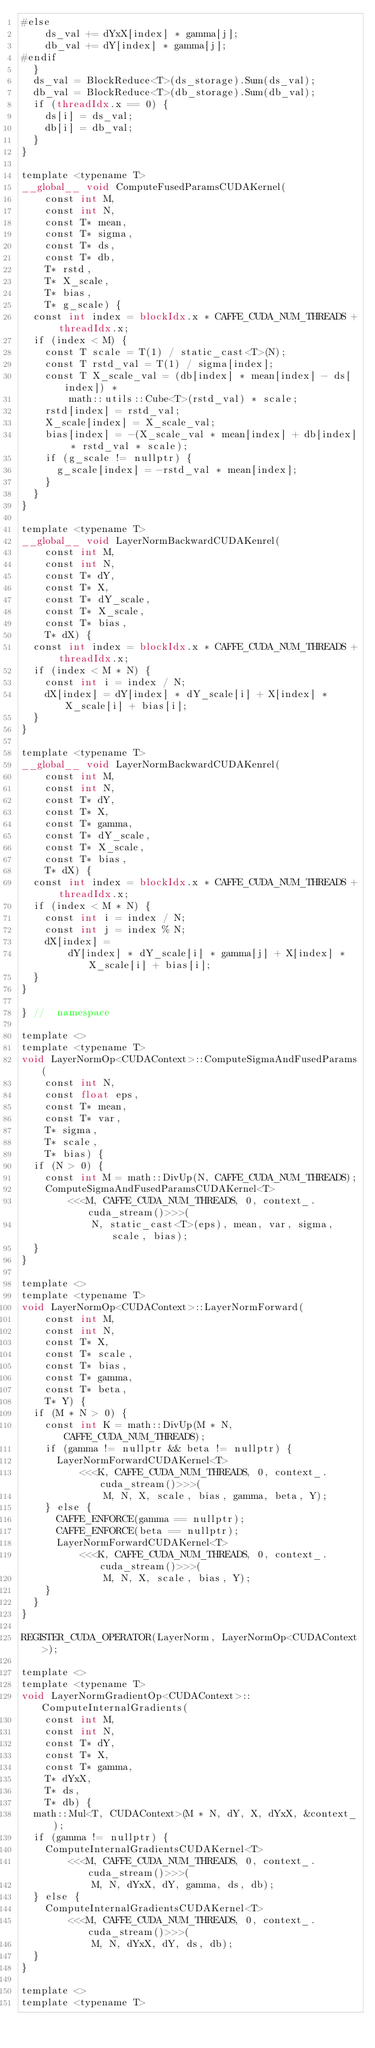Convert code to text. <code><loc_0><loc_0><loc_500><loc_500><_Cuda_>#else
    ds_val += dYxX[index] * gamma[j];
    db_val += dY[index] * gamma[j];
#endif
  }
  ds_val = BlockReduce<T>(ds_storage).Sum(ds_val);
  db_val = BlockReduce<T>(db_storage).Sum(db_val);
  if (threadIdx.x == 0) {
    ds[i] = ds_val;
    db[i] = db_val;
  }
}

template <typename T>
__global__ void ComputeFusedParamsCUDAKernel(
    const int M,
    const int N,
    const T* mean,
    const T* sigma,
    const T* ds,
    const T* db,
    T* rstd,
    T* X_scale,
    T* bias,
    T* g_scale) {
  const int index = blockIdx.x * CAFFE_CUDA_NUM_THREADS + threadIdx.x;
  if (index < M) {
    const T scale = T(1) / static_cast<T>(N);
    const T rstd_val = T(1) / sigma[index];
    const T X_scale_val = (db[index] * mean[index] - ds[index]) *
        math::utils::Cube<T>(rstd_val) * scale;
    rstd[index] = rstd_val;
    X_scale[index] = X_scale_val;
    bias[index] = -(X_scale_val * mean[index] + db[index] * rstd_val * scale);
    if (g_scale != nullptr) {
      g_scale[index] = -rstd_val * mean[index];
    }
  }
}

template <typename T>
__global__ void LayerNormBackwardCUDAKenrel(
    const int M,
    const int N,
    const T* dY,
    const T* X,
    const T* dY_scale,
    const T* X_scale,
    const T* bias,
    T* dX) {
  const int index = blockIdx.x * CAFFE_CUDA_NUM_THREADS + threadIdx.x;
  if (index < M * N) {
    const int i = index / N;
    dX[index] = dY[index] * dY_scale[i] + X[index] * X_scale[i] + bias[i];
  }
}

template <typename T>
__global__ void LayerNormBackwardCUDAKenrel(
    const int M,
    const int N,
    const T* dY,
    const T* X,
    const T* gamma,
    const T* dY_scale,
    const T* X_scale,
    const T* bias,
    T* dX) {
  const int index = blockIdx.x * CAFFE_CUDA_NUM_THREADS + threadIdx.x;
  if (index < M * N) {
    const int i = index / N;
    const int j = index % N;
    dX[index] =
        dY[index] * dY_scale[i] * gamma[j] + X[index] * X_scale[i] + bias[i];
  }
}

} //  namespace

template <>
template <typename T>
void LayerNormOp<CUDAContext>::ComputeSigmaAndFusedParams(
    const int N,
    const float eps,
    const T* mean,
    const T* var,
    T* sigma,
    T* scale,
    T* bias) {
  if (N > 0) {
    const int M = math::DivUp(N, CAFFE_CUDA_NUM_THREADS);
    ComputeSigmaAndFusedParamsCUDAKernel<T>
        <<<M, CAFFE_CUDA_NUM_THREADS, 0, context_.cuda_stream()>>>(
            N, static_cast<T>(eps), mean, var, sigma, scale, bias);
  }
}

template <>
template <typename T>
void LayerNormOp<CUDAContext>::LayerNormForward(
    const int M,
    const int N,
    const T* X,
    const T* scale,
    const T* bias,
    const T* gamma,
    const T* beta,
    T* Y) {
  if (M * N > 0) {
    const int K = math::DivUp(M * N, CAFFE_CUDA_NUM_THREADS);
    if (gamma != nullptr && beta != nullptr) {
      LayerNormForwardCUDAKernel<T>
          <<<K, CAFFE_CUDA_NUM_THREADS, 0, context_.cuda_stream()>>>(
              M, N, X, scale, bias, gamma, beta, Y);
    } else {
      CAFFE_ENFORCE(gamma == nullptr);
      CAFFE_ENFORCE(beta == nullptr);
      LayerNormForwardCUDAKernel<T>
          <<<K, CAFFE_CUDA_NUM_THREADS, 0, context_.cuda_stream()>>>(
              M, N, X, scale, bias, Y);
    }
  }
}

REGISTER_CUDA_OPERATOR(LayerNorm, LayerNormOp<CUDAContext>);

template <>
template <typename T>
void LayerNormGradientOp<CUDAContext>::ComputeInternalGradients(
    const int M,
    const int N,
    const T* dY,
    const T* X,
    const T* gamma,
    T* dYxX,
    T* ds,
    T* db) {
  math::Mul<T, CUDAContext>(M * N, dY, X, dYxX, &context_);
  if (gamma != nullptr) {
    ComputeInternalGradientsCUDAKernel<T>
        <<<M, CAFFE_CUDA_NUM_THREADS, 0, context_.cuda_stream()>>>(
            M, N, dYxX, dY, gamma, ds, db);
  } else {
    ComputeInternalGradientsCUDAKernel<T>
        <<<M, CAFFE_CUDA_NUM_THREADS, 0, context_.cuda_stream()>>>(
            M, N, dYxX, dY, ds, db);
  }
}

template <>
template <typename T></code> 